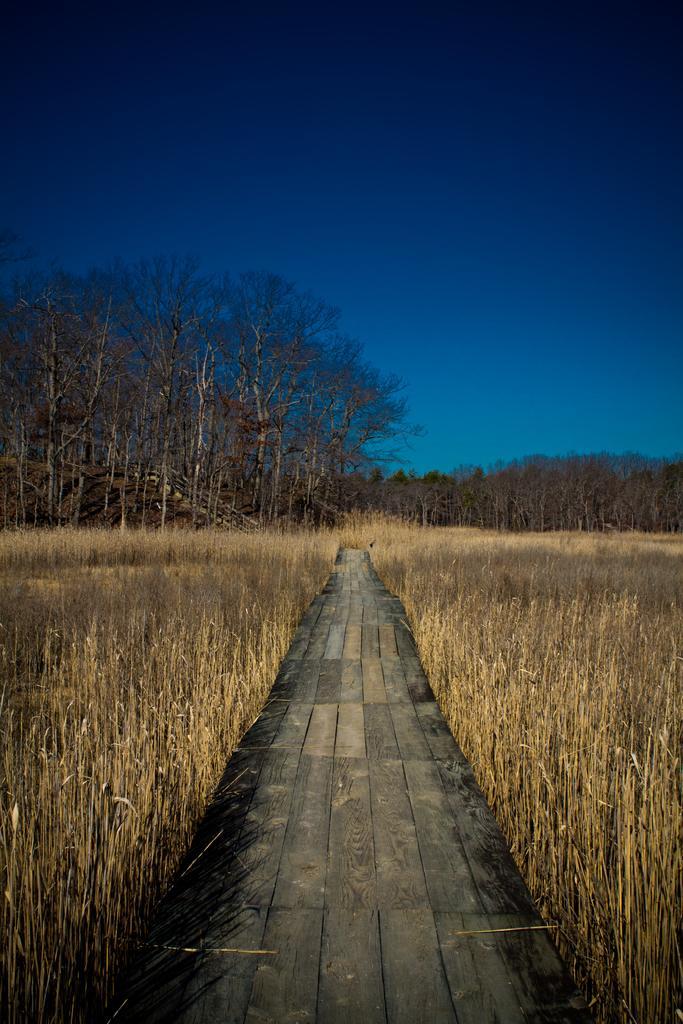In one or two sentences, can you explain what this image depicts? In the image we can see there is a wooden bridge and on the either sides there are dry plants and behind there are lot of trees. There is clear sky on the top. 